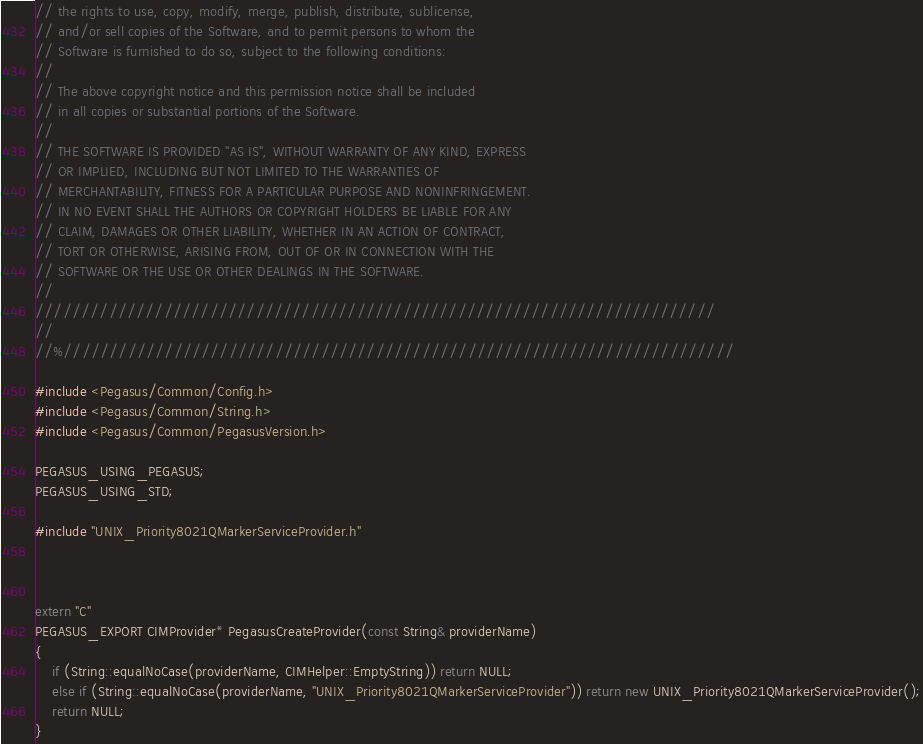<code> <loc_0><loc_0><loc_500><loc_500><_C++_>// the rights to use, copy, modify, merge, publish, distribute, sublicense,
// and/or sell copies of the Software, and to permit persons to whom the
// Software is furnished to do so, subject to the following conditions:
//
// The above copyright notice and this permission notice shall be included
// in all copies or substantial portions of the Software.
//
// THE SOFTWARE IS PROVIDED "AS IS", WITHOUT WARRANTY OF ANY KIND, EXPRESS
// OR IMPLIED, INCLUDING BUT NOT LIMITED TO THE WARRANTIES OF
// MERCHANTABILITY, FITNESS FOR A PARTICULAR PURPOSE AND NONINFRINGEMENT.
// IN NO EVENT SHALL THE AUTHORS OR COPYRIGHT HOLDERS BE LIABLE FOR ANY
// CLAIM, DAMAGES OR OTHER LIABILITY, WHETHER IN AN ACTION OF CONTRACT,
// TORT OR OTHERWISE, ARISING FROM, OUT OF OR IN CONNECTION WITH THE
// SOFTWARE OR THE USE OR OTHER DEALINGS IN THE SOFTWARE.
//
//////////////////////////////////////////////////////////////////////////
//
//%/////////////////////////////////////////////////////////////////////////

#include <Pegasus/Common/Config.h>
#include <Pegasus/Common/String.h>
#include <Pegasus/Common/PegasusVersion.h>

PEGASUS_USING_PEGASUS;
PEGASUS_USING_STD;

#include "UNIX_Priority8021QMarkerServiceProvider.h"



extern "C"
PEGASUS_EXPORT CIMProvider* PegasusCreateProvider(const String& providerName)
{
	if (String::equalNoCase(providerName, CIMHelper::EmptyString)) return NULL;
	else if (String::equalNoCase(providerName, "UNIX_Priority8021QMarkerServiceProvider")) return new UNIX_Priority8021QMarkerServiceProvider();
	return NULL;
}


</code> 